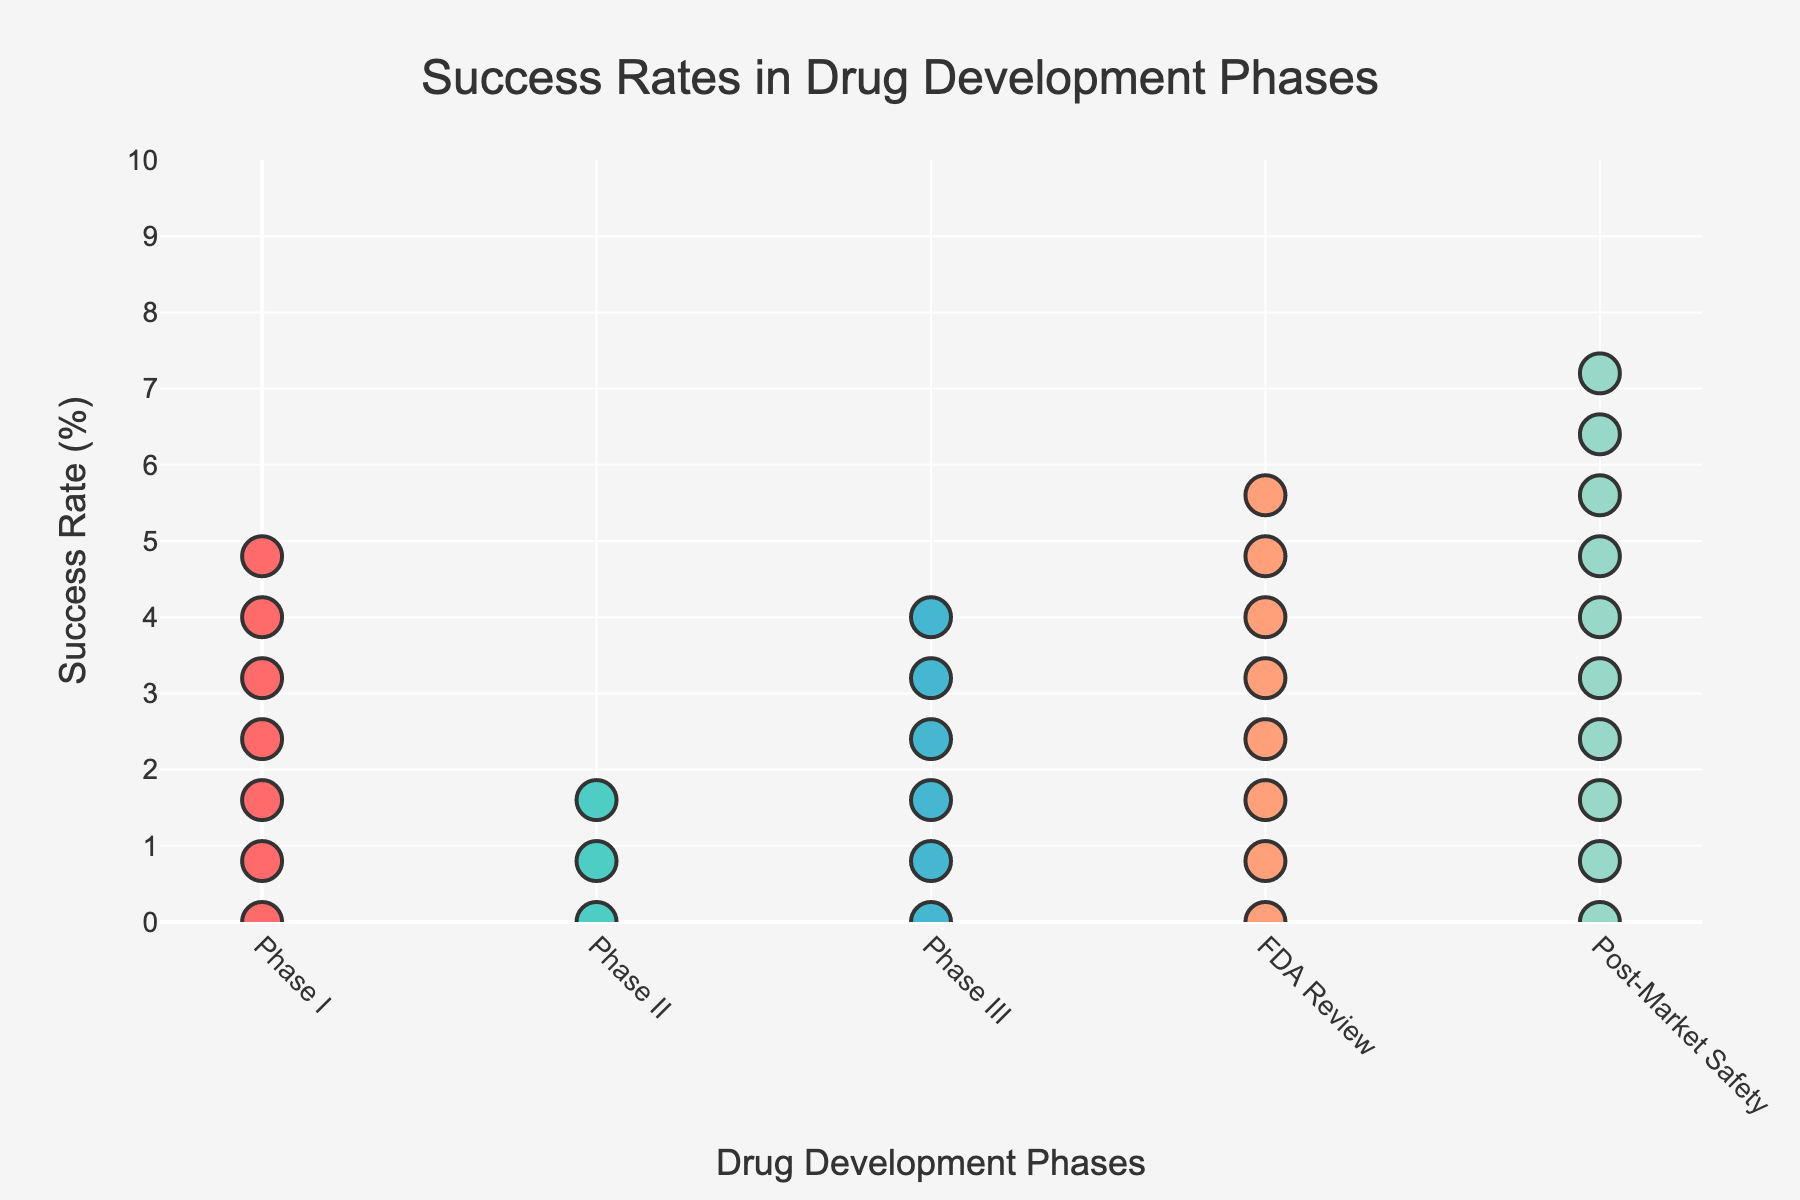How many drug development phases are represented in the figure? The x-axis shows the different drug development phases. By counting the distinct labels on the x-axis, we can determine the number of phases represented.
Answer: 5 Which drug development phase has the highest success rate? We need to look at each drug development phase and identify the one with the highest percent value. The annotations on top of each column will help.
Answer: Post-Market Safety What is the difference in success rates between Phase II and Phase III? Refer to the annotations for Phase II and Phase III. Phase II has a success rate of 33%, and Phase III has 59%. Subtract the smaller from the larger value to get the difference.
Answer: 26% Which phase has the lowest number of trials per 100? Look at the annotations below each phase which indicate the number of trials per 100. Identify the smallest value.
Answer: Post-Market Safety In which phases is the success rate above 50%? Review the annotations on top of each column. Identify columns with a value greater than 50%.
Answer: Phase I, Phase III, FDA Review, Post-Market Safety What is the total number of trials per 100, combining all phases? Add the values for trials per 100 from all phases: 100, 67, 22, 13, 11.
Answer: 213 Compare the number of trials per 100 between Phase I and Phase II. Which one has more and by how much? Check the annotations beneath Phase I and Phase II. Phase I has 100 trials, and Phase II has 67. Subtract the smaller number from the larger one.
Answer: Phase I has 33 more trials What is the average success rate of all the drug development phases shown in the plot? Sum the success rates of all phases and divide by the number of phases: (67 + 33 + 59 + 85 + 98) / 5.
Answer: 68.4% If you combine the success rates of Phase I and FDA Review, is it more than the Post-Market Safety phase? Add the success rates of Phase I and FDA Review: 67% + 85%. Compare the sum with the Safety phase's 98%.
Answer: Yes Why does the Post-Market Safety phase have such a high success rate compared to Phase II? Consider the nature of these phases. Post-Market Safety involves monitoring drugs that have already been approved, which likely have established effectiveness, compared to Phase II, where the drug is still under investigation.
Answer: Post-Market Safety involves already approved and tested drugs 